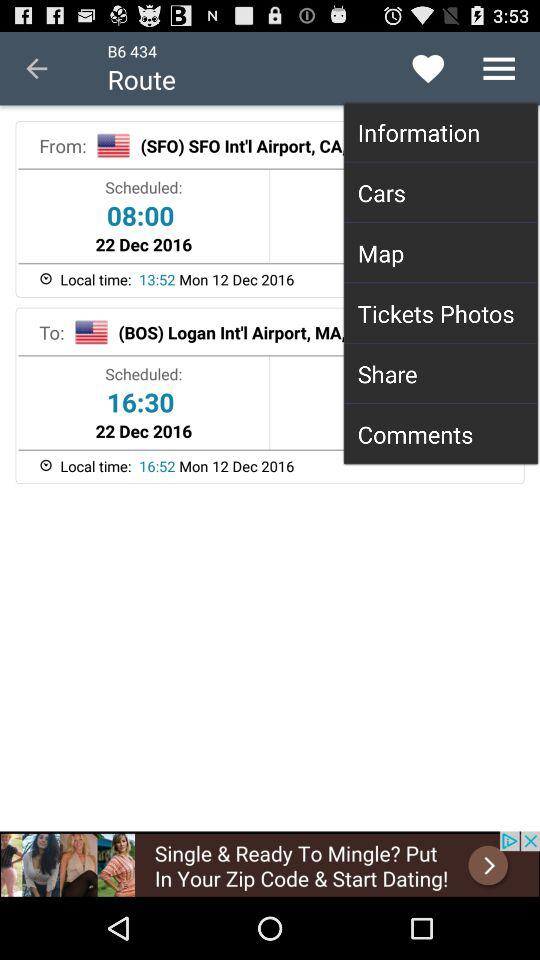What is the local time at the destination airport?
Answer the question using a single word or phrase. 16:52 Mon 12 Dec 2016 